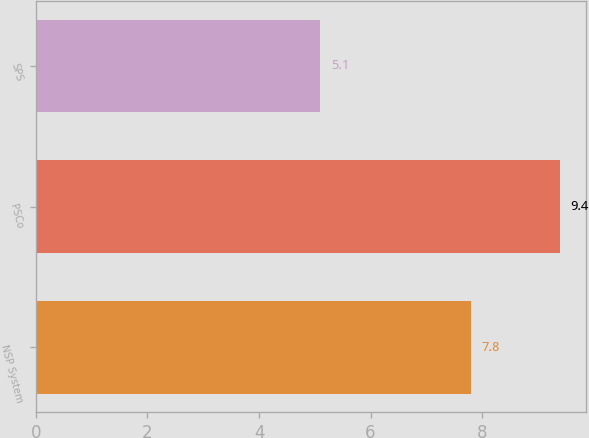Convert chart. <chart><loc_0><loc_0><loc_500><loc_500><bar_chart><fcel>NSP System<fcel>PSCo<fcel>SPS<nl><fcel>7.8<fcel>9.4<fcel>5.1<nl></chart> 